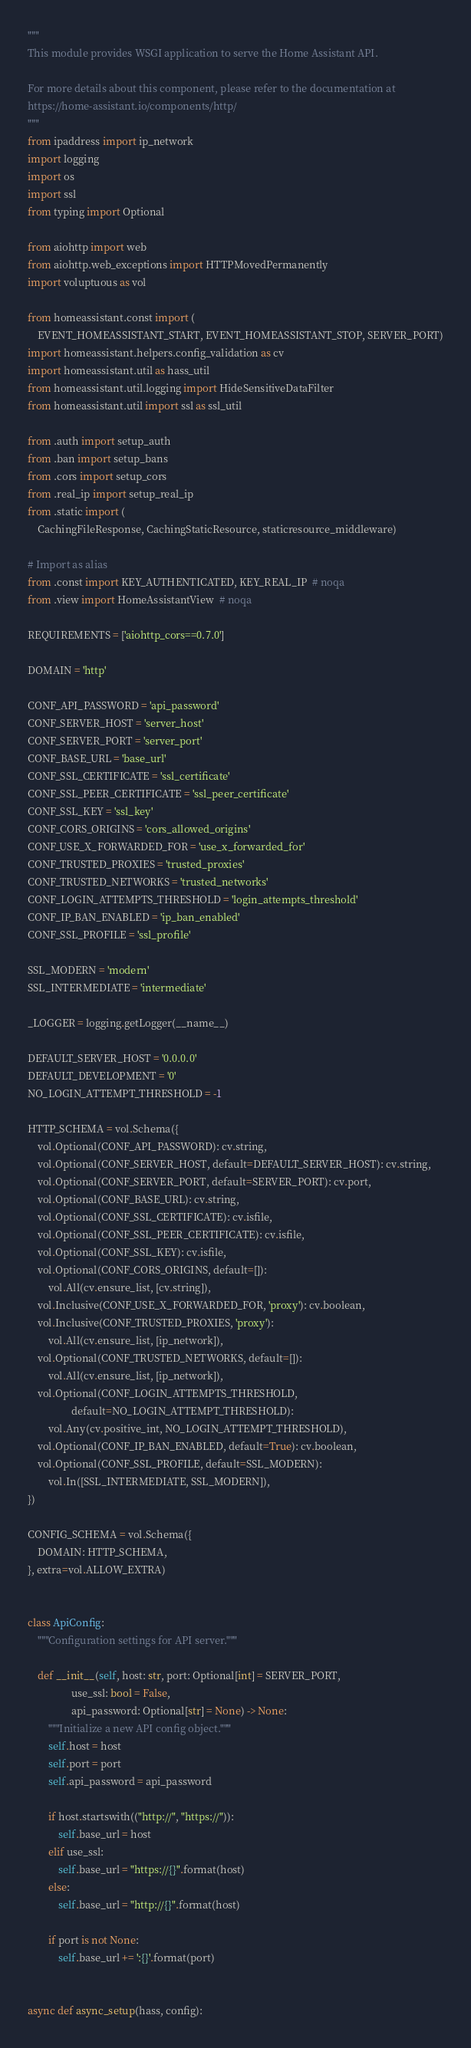Convert code to text. <code><loc_0><loc_0><loc_500><loc_500><_Python_>"""
This module provides WSGI application to serve the Home Assistant API.

For more details about this component, please refer to the documentation at
https://home-assistant.io/components/http/
"""
from ipaddress import ip_network
import logging
import os
import ssl
from typing import Optional

from aiohttp import web
from aiohttp.web_exceptions import HTTPMovedPermanently
import voluptuous as vol

from homeassistant.const import (
    EVENT_HOMEASSISTANT_START, EVENT_HOMEASSISTANT_STOP, SERVER_PORT)
import homeassistant.helpers.config_validation as cv
import homeassistant.util as hass_util
from homeassistant.util.logging import HideSensitiveDataFilter
from homeassistant.util import ssl as ssl_util

from .auth import setup_auth
from .ban import setup_bans
from .cors import setup_cors
from .real_ip import setup_real_ip
from .static import (
    CachingFileResponse, CachingStaticResource, staticresource_middleware)

# Import as alias
from .const import KEY_AUTHENTICATED, KEY_REAL_IP  # noqa
from .view import HomeAssistantView  # noqa

REQUIREMENTS = ['aiohttp_cors==0.7.0']

DOMAIN = 'http'

CONF_API_PASSWORD = 'api_password'
CONF_SERVER_HOST = 'server_host'
CONF_SERVER_PORT = 'server_port'
CONF_BASE_URL = 'base_url'
CONF_SSL_CERTIFICATE = 'ssl_certificate'
CONF_SSL_PEER_CERTIFICATE = 'ssl_peer_certificate'
CONF_SSL_KEY = 'ssl_key'
CONF_CORS_ORIGINS = 'cors_allowed_origins'
CONF_USE_X_FORWARDED_FOR = 'use_x_forwarded_for'
CONF_TRUSTED_PROXIES = 'trusted_proxies'
CONF_TRUSTED_NETWORKS = 'trusted_networks'
CONF_LOGIN_ATTEMPTS_THRESHOLD = 'login_attempts_threshold'
CONF_IP_BAN_ENABLED = 'ip_ban_enabled'
CONF_SSL_PROFILE = 'ssl_profile'

SSL_MODERN = 'modern'
SSL_INTERMEDIATE = 'intermediate'

_LOGGER = logging.getLogger(__name__)

DEFAULT_SERVER_HOST = '0.0.0.0'
DEFAULT_DEVELOPMENT = '0'
NO_LOGIN_ATTEMPT_THRESHOLD = -1

HTTP_SCHEMA = vol.Schema({
    vol.Optional(CONF_API_PASSWORD): cv.string,
    vol.Optional(CONF_SERVER_HOST, default=DEFAULT_SERVER_HOST): cv.string,
    vol.Optional(CONF_SERVER_PORT, default=SERVER_PORT): cv.port,
    vol.Optional(CONF_BASE_URL): cv.string,
    vol.Optional(CONF_SSL_CERTIFICATE): cv.isfile,
    vol.Optional(CONF_SSL_PEER_CERTIFICATE): cv.isfile,
    vol.Optional(CONF_SSL_KEY): cv.isfile,
    vol.Optional(CONF_CORS_ORIGINS, default=[]):
        vol.All(cv.ensure_list, [cv.string]),
    vol.Inclusive(CONF_USE_X_FORWARDED_FOR, 'proxy'): cv.boolean,
    vol.Inclusive(CONF_TRUSTED_PROXIES, 'proxy'):
        vol.All(cv.ensure_list, [ip_network]),
    vol.Optional(CONF_TRUSTED_NETWORKS, default=[]):
        vol.All(cv.ensure_list, [ip_network]),
    vol.Optional(CONF_LOGIN_ATTEMPTS_THRESHOLD,
                 default=NO_LOGIN_ATTEMPT_THRESHOLD):
        vol.Any(cv.positive_int, NO_LOGIN_ATTEMPT_THRESHOLD),
    vol.Optional(CONF_IP_BAN_ENABLED, default=True): cv.boolean,
    vol.Optional(CONF_SSL_PROFILE, default=SSL_MODERN):
        vol.In([SSL_INTERMEDIATE, SSL_MODERN]),
})

CONFIG_SCHEMA = vol.Schema({
    DOMAIN: HTTP_SCHEMA,
}, extra=vol.ALLOW_EXTRA)


class ApiConfig:
    """Configuration settings for API server."""

    def __init__(self, host: str, port: Optional[int] = SERVER_PORT,
                 use_ssl: bool = False,
                 api_password: Optional[str] = None) -> None:
        """Initialize a new API config object."""
        self.host = host
        self.port = port
        self.api_password = api_password

        if host.startswith(("http://", "https://")):
            self.base_url = host
        elif use_ssl:
            self.base_url = "https://{}".format(host)
        else:
            self.base_url = "http://{}".format(host)

        if port is not None:
            self.base_url += ':{}'.format(port)


async def async_setup(hass, config):</code> 